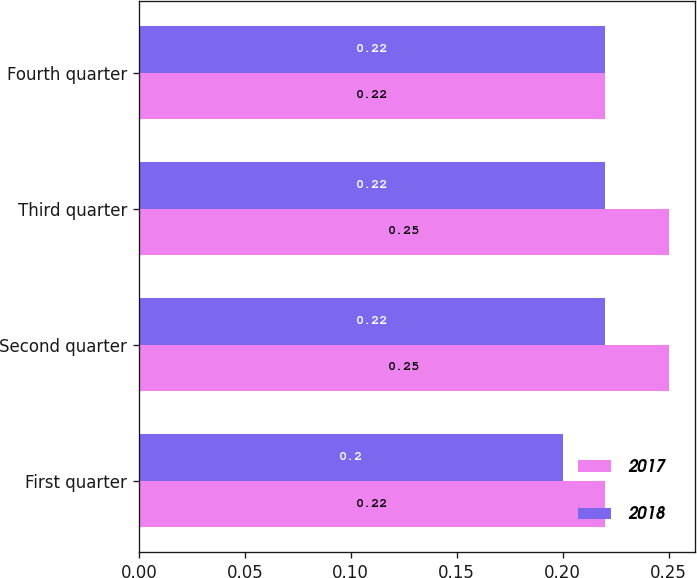Convert chart. <chart><loc_0><loc_0><loc_500><loc_500><stacked_bar_chart><ecel><fcel>First quarter<fcel>Second quarter<fcel>Third quarter<fcel>Fourth quarter<nl><fcel>2017<fcel>0.22<fcel>0.25<fcel>0.25<fcel>0.22<nl><fcel>2018<fcel>0.2<fcel>0.22<fcel>0.22<fcel>0.22<nl></chart> 